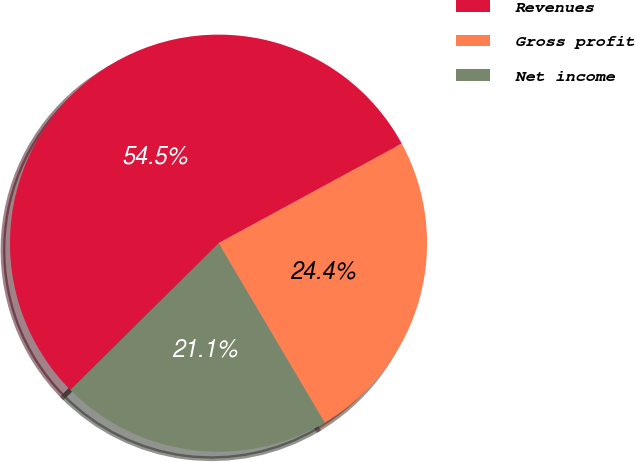<chart> <loc_0><loc_0><loc_500><loc_500><pie_chart><fcel>Revenues<fcel>Gross profit<fcel>Net income<nl><fcel>54.5%<fcel>24.42%<fcel>21.08%<nl></chart> 